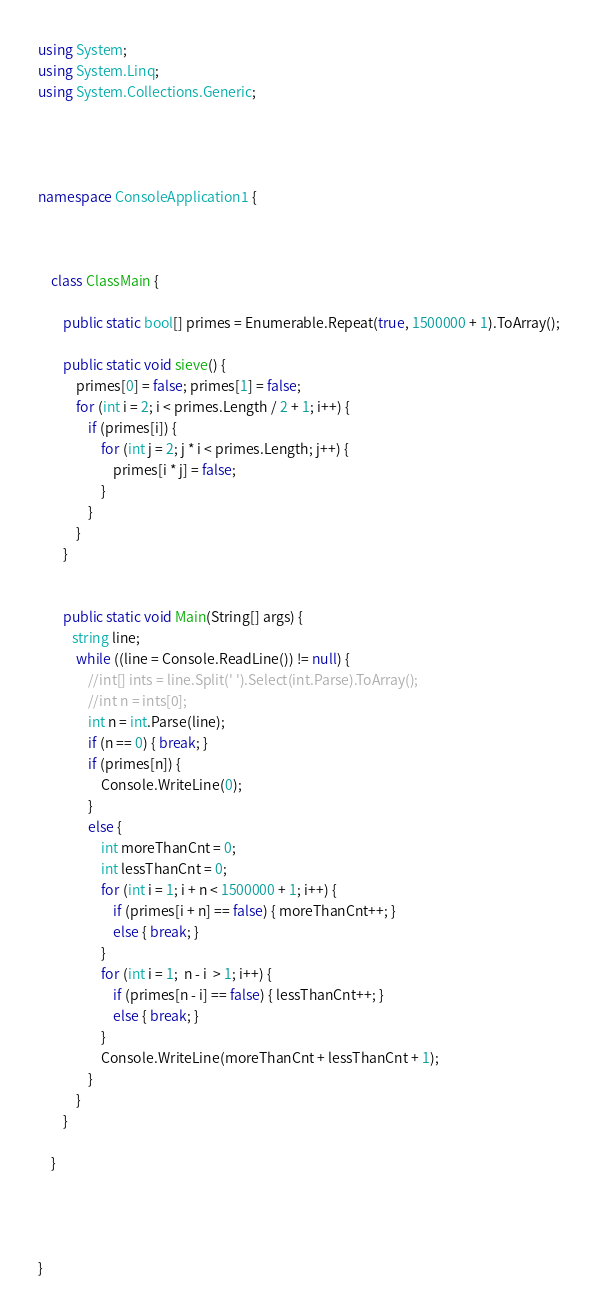<code> <loc_0><loc_0><loc_500><loc_500><_C#_>using System;
using System.Linq;
using System.Collections.Generic;




namespace ConsoleApplication1 {

    

    class ClassMain {

        public static bool[] primes = Enumerable.Repeat(true, 1500000 + 1).ToArray();

        public static void sieve() {
            primes[0] = false; primes[1] = false;
            for (int i = 2; i < primes.Length / 2 + 1; i++) {
                if (primes[i]) {
                    for (int j = 2; j * i < primes.Length; j++) {
                        primes[i * j] = false;
                    }
                }
            }
        }


        public static void Main(String[] args) {
           string line;
            while ((line = Console.ReadLine()) != null) {
                //int[] ints = line.Split(' ').Select(int.Parse).ToArray();
                //int n = ints[0];
                int n = int.Parse(line);                
                if (n == 0) { break; }
                if (primes[n]) {
                    Console.WriteLine(0);
                }
                else {
                    int moreThanCnt = 0;
                    int lessThanCnt = 0;
                    for (int i = 1; i + n < 1500000 + 1; i++) {
                        if (primes[i + n] == false) { moreThanCnt++; }
                        else { break; }
                    }
                    for (int i = 1;  n - i  > 1; i++) {
                        if (primes[n - i] == false) { lessThanCnt++; }
                        else { break; }
                    }
                    Console.WriteLine(moreThanCnt + lessThanCnt + 1);
                }
            }
        }

    }

    


}</code> 